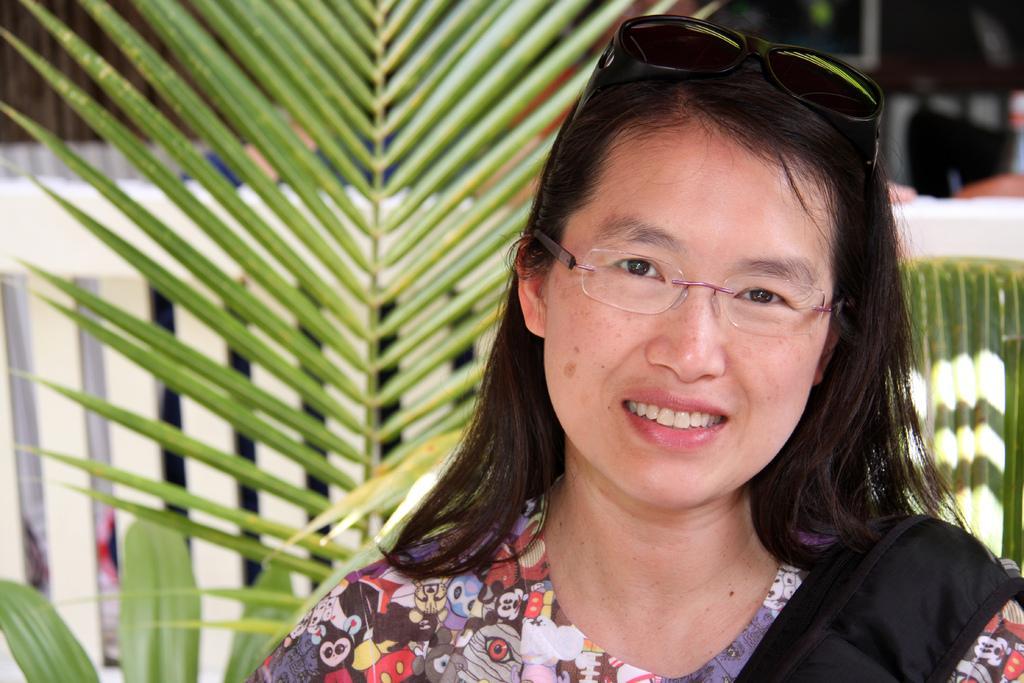Could you give a brief overview of what you see in this image? In this image we can see a woman wearing spectacles. On the backside we can see some plants. 